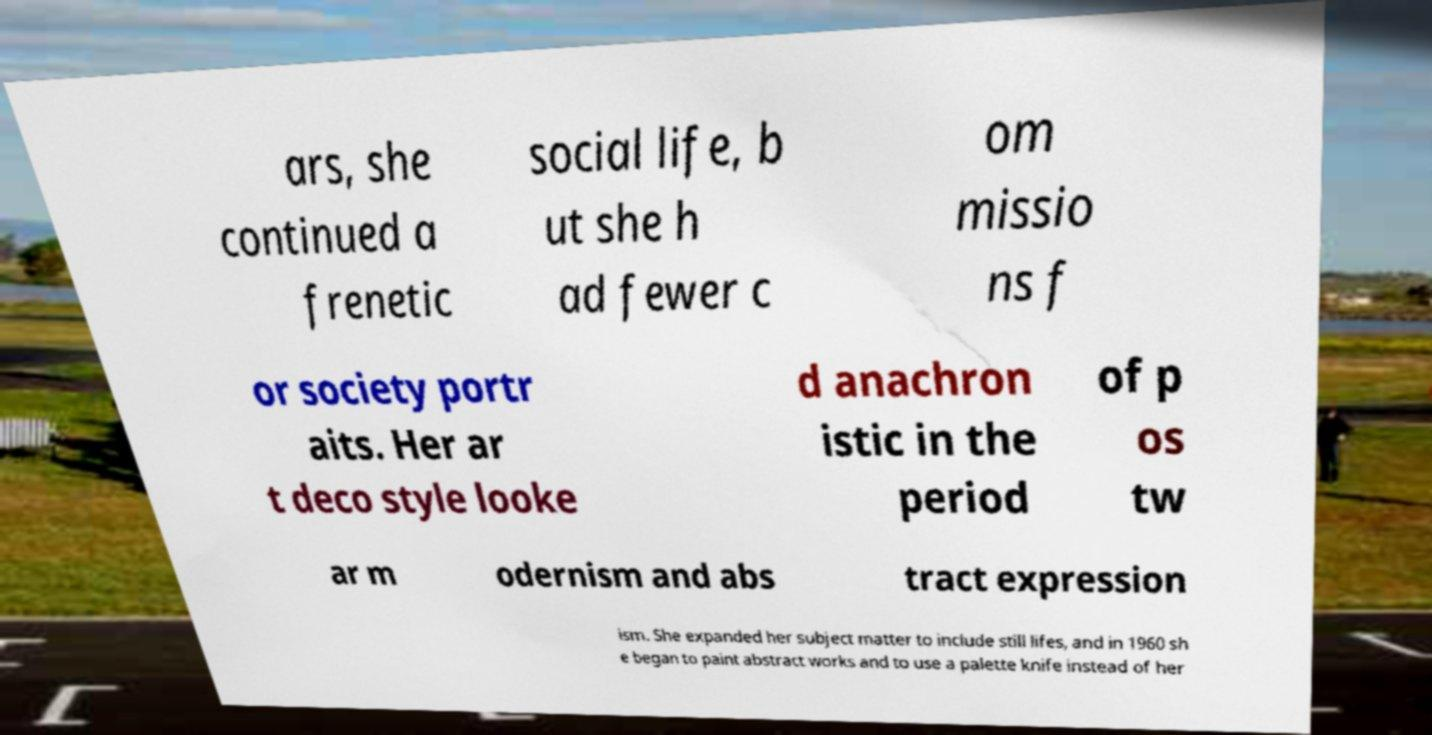Could you extract and type out the text from this image? ars, she continued a frenetic social life, b ut she h ad fewer c om missio ns f or society portr aits. Her ar t deco style looke d anachron istic in the period of p os tw ar m odernism and abs tract expression ism. She expanded her subject matter to include still lifes, and in 1960 sh e began to paint abstract works and to use a palette knife instead of her 